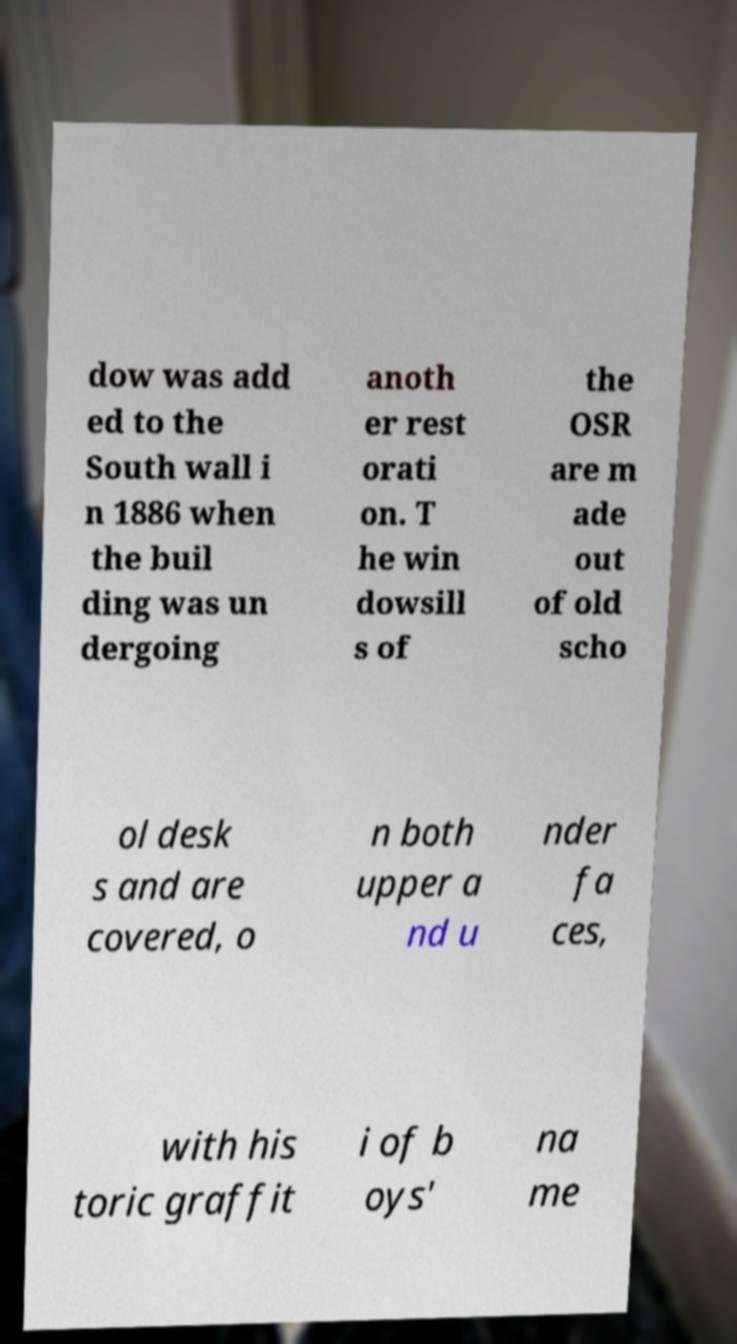I need the written content from this picture converted into text. Can you do that? dow was add ed to the South wall i n 1886 when the buil ding was un dergoing anoth er rest orati on. T he win dowsill s of the OSR are m ade out of old scho ol desk s and are covered, o n both upper a nd u nder fa ces, with his toric graffit i of b oys' na me 